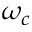Convert formula to latex. <formula><loc_0><loc_0><loc_500><loc_500>\omega _ { c }</formula> 